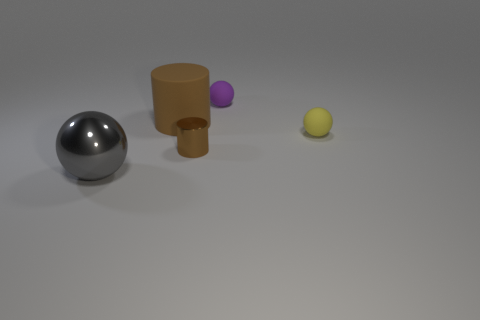What is the material of the other ball that is the same size as the yellow sphere?
Offer a terse response. Rubber. How many metal objects are small brown cylinders or yellow spheres?
Your response must be concise. 1. What is the color of the thing that is to the right of the large brown cylinder and in front of the yellow matte object?
Ensure brevity in your answer.  Brown. There is a big gray ball; how many yellow balls are left of it?
Provide a short and direct response. 0. What is the small purple thing made of?
Offer a very short reply. Rubber. The metallic thing in front of the cylinder that is in front of the small rubber object that is in front of the small purple rubber ball is what color?
Your response must be concise. Gray. How many balls are the same size as the yellow matte object?
Provide a succinct answer. 1. What color is the shiny thing to the left of the tiny brown cylinder?
Ensure brevity in your answer.  Gray. What number of other objects are there of the same size as the brown metal cylinder?
Provide a short and direct response. 2. What is the size of the object that is both left of the tiny purple rubber sphere and behind the yellow matte object?
Offer a terse response. Large. 